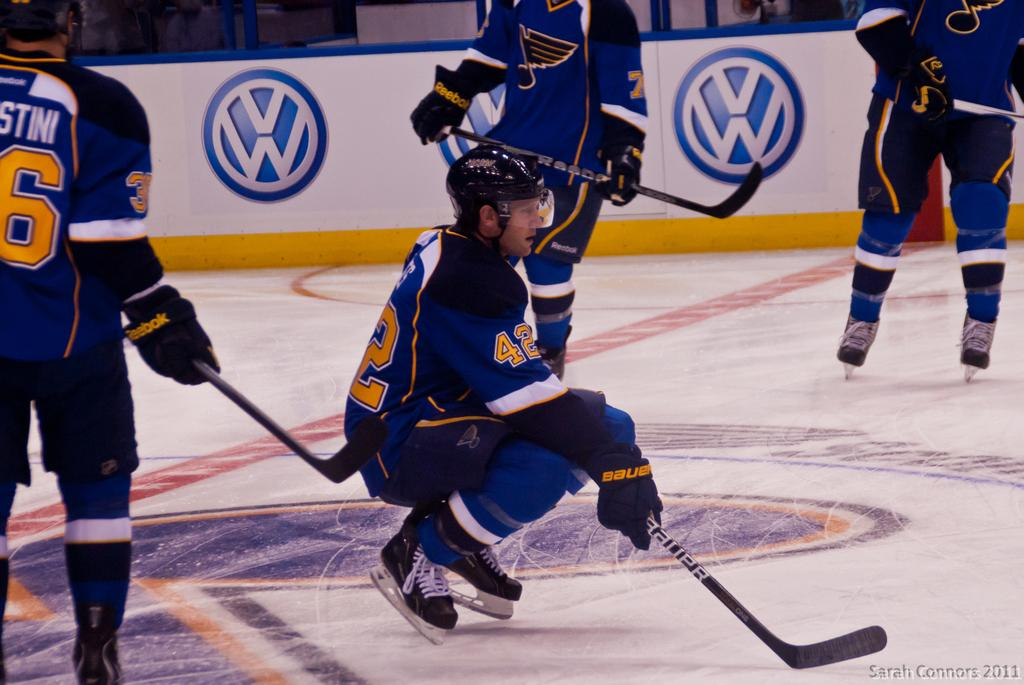What activity are the four persons engaged in within the image? The four persons are playing ice hockey in the image. Where is the ice hockey game taking place? The ice hockey game is taking place at the bottom of the image. What can be seen in the background of the image? There is a boundary wall in the background of the image. How many chairs are visible in the image? There are no chairs visible in the image; it features four persons playing ice hockey and a boundary wall in the background. 